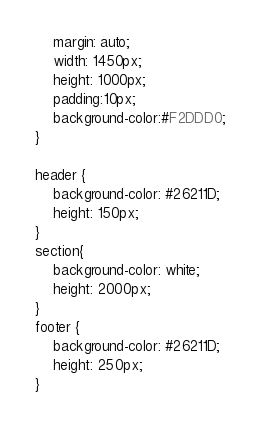Convert code to text. <code><loc_0><loc_0><loc_500><loc_500><_CSS_>    margin: auto; 
    width: 1450px;
    height: 1000px;
    padding:10px;
    background-color:#F2DDD0;
}

header {
    background-color: #26211D;
    height: 150px;    
}
section{
    background-color: white;
    height: 2000px;   
}
footer {
    background-color: #26211D;
    height: 250px;    
}</code> 